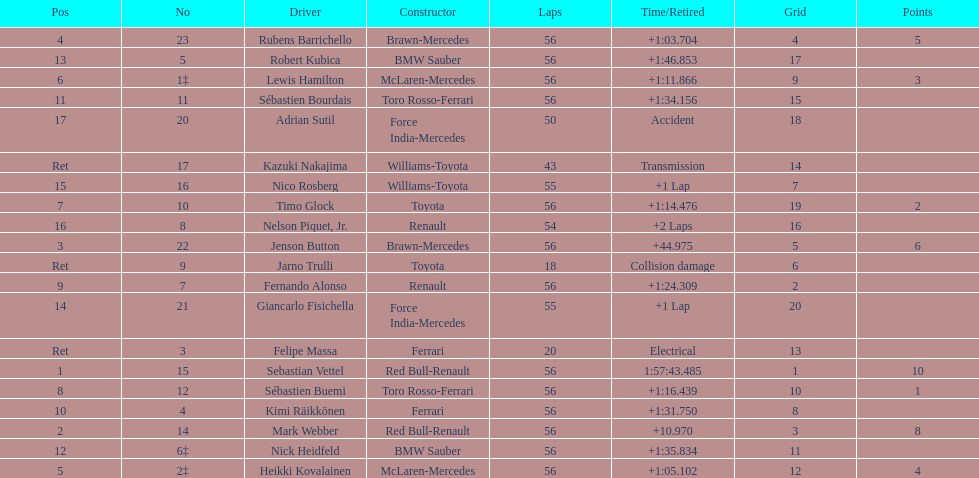How many laps in total is the race? 56. 